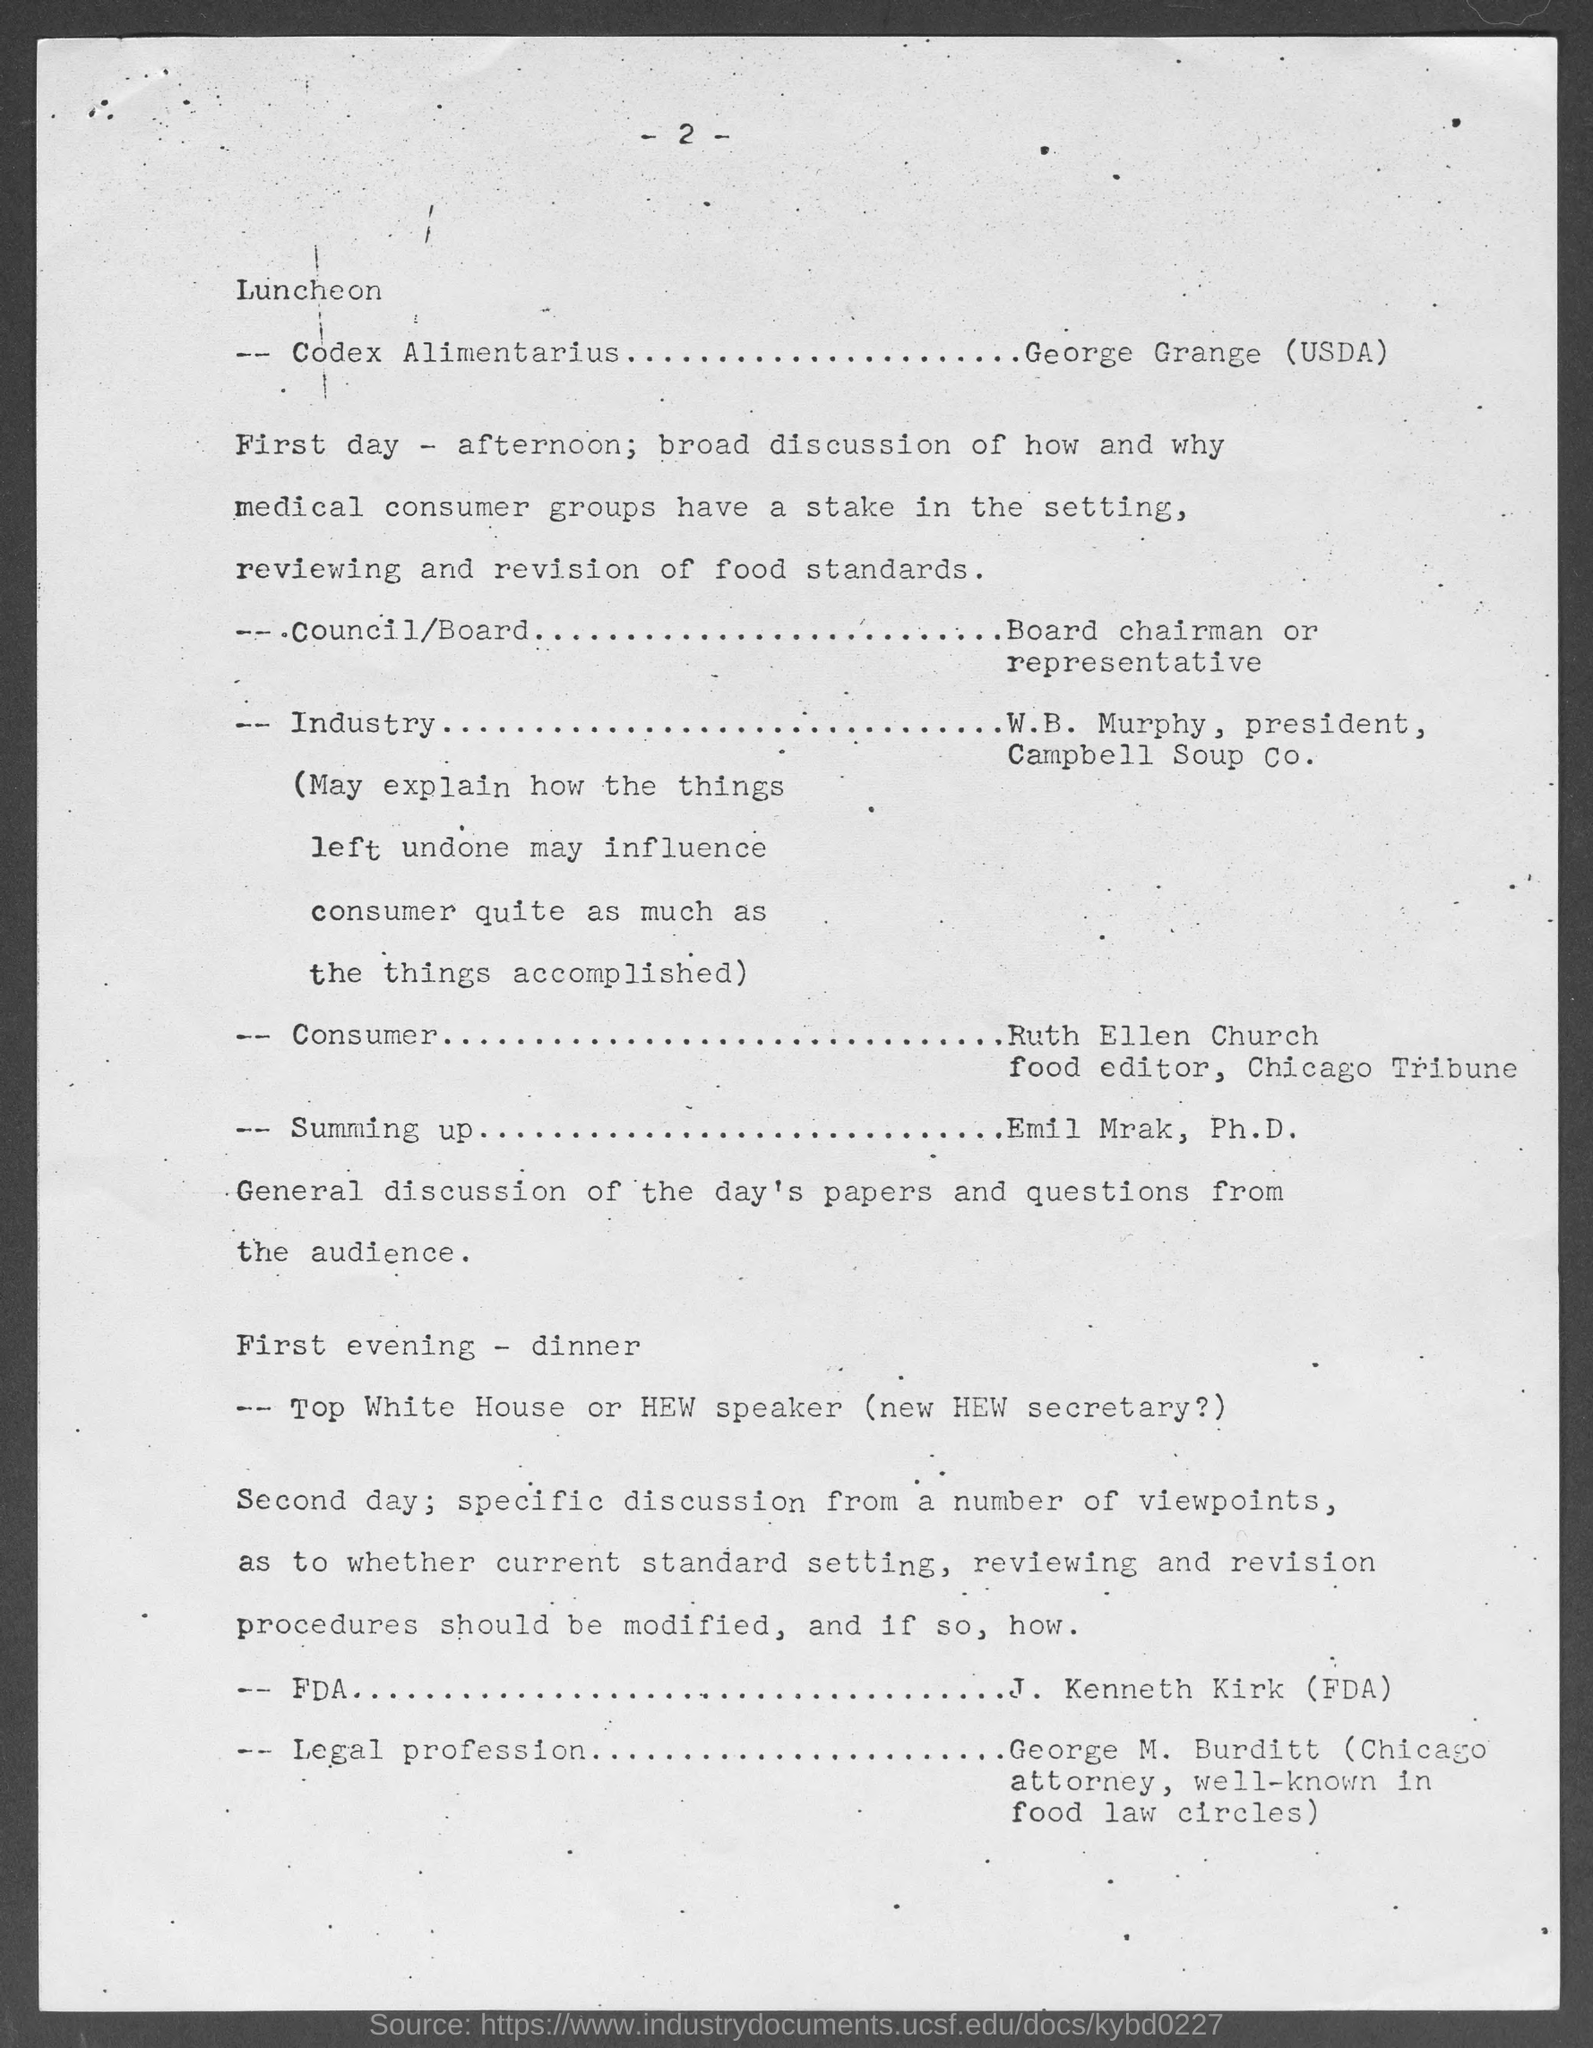What is the page number?
Your answer should be compact. 2. Who is the president of Campbell Soup Co.?
Your answer should be very brief. W.B. Murphy. 